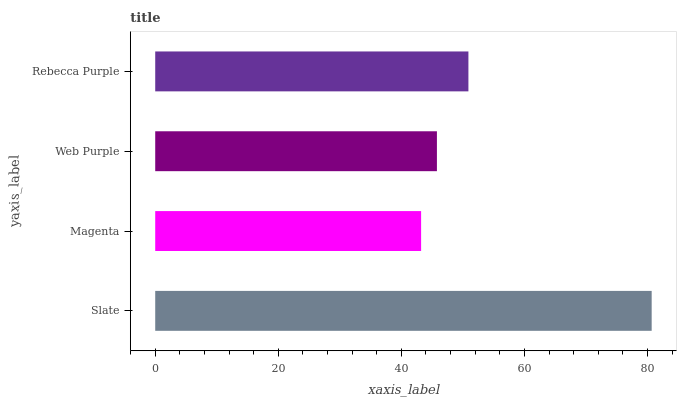Is Magenta the minimum?
Answer yes or no. Yes. Is Slate the maximum?
Answer yes or no. Yes. Is Web Purple the minimum?
Answer yes or no. No. Is Web Purple the maximum?
Answer yes or no. No. Is Web Purple greater than Magenta?
Answer yes or no. Yes. Is Magenta less than Web Purple?
Answer yes or no. Yes. Is Magenta greater than Web Purple?
Answer yes or no. No. Is Web Purple less than Magenta?
Answer yes or no. No. Is Rebecca Purple the high median?
Answer yes or no. Yes. Is Web Purple the low median?
Answer yes or no. Yes. Is Web Purple the high median?
Answer yes or no. No. Is Slate the low median?
Answer yes or no. No. 